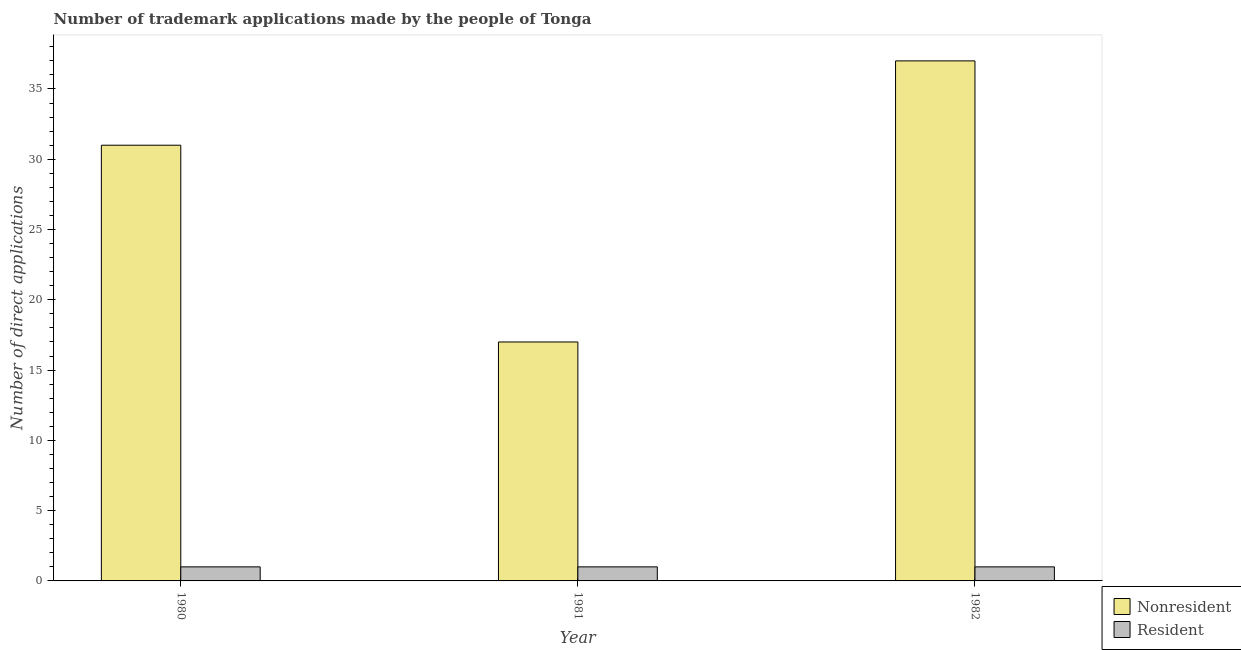How many groups of bars are there?
Ensure brevity in your answer.  3. How many bars are there on the 2nd tick from the left?
Provide a short and direct response. 2. How many bars are there on the 2nd tick from the right?
Provide a short and direct response. 2. In how many cases, is the number of bars for a given year not equal to the number of legend labels?
Offer a very short reply. 0. What is the number of trademark applications made by residents in 1982?
Ensure brevity in your answer.  1. Across all years, what is the maximum number of trademark applications made by residents?
Offer a terse response. 1. Across all years, what is the minimum number of trademark applications made by non residents?
Provide a short and direct response. 17. What is the total number of trademark applications made by residents in the graph?
Offer a very short reply. 3. What is the difference between the number of trademark applications made by non residents in 1982 and the number of trademark applications made by residents in 1980?
Keep it short and to the point. 6. What is the average number of trademark applications made by non residents per year?
Make the answer very short. 28.33. In the year 1982, what is the difference between the number of trademark applications made by residents and number of trademark applications made by non residents?
Make the answer very short. 0. In how many years, is the number of trademark applications made by residents greater than 4?
Provide a succinct answer. 0. What is the ratio of the number of trademark applications made by residents in 1980 to that in 1982?
Ensure brevity in your answer.  1. Is the number of trademark applications made by residents in 1980 less than that in 1982?
Your response must be concise. No. What is the difference between the highest and the second highest number of trademark applications made by non residents?
Your answer should be compact. 6. What is the difference between the highest and the lowest number of trademark applications made by non residents?
Keep it short and to the point. 20. In how many years, is the number of trademark applications made by non residents greater than the average number of trademark applications made by non residents taken over all years?
Your answer should be compact. 2. Is the sum of the number of trademark applications made by residents in 1981 and 1982 greater than the maximum number of trademark applications made by non residents across all years?
Make the answer very short. Yes. What does the 2nd bar from the left in 1982 represents?
Your answer should be very brief. Resident. What does the 1st bar from the right in 1982 represents?
Make the answer very short. Resident. Are all the bars in the graph horizontal?
Provide a succinct answer. No. How many years are there in the graph?
Provide a short and direct response. 3. What is the difference between two consecutive major ticks on the Y-axis?
Give a very brief answer. 5. Does the graph contain grids?
Offer a terse response. No. Where does the legend appear in the graph?
Your answer should be compact. Bottom right. How many legend labels are there?
Your answer should be very brief. 2. How are the legend labels stacked?
Make the answer very short. Vertical. What is the title of the graph?
Offer a very short reply. Number of trademark applications made by the people of Tonga. Does "Researchers" appear as one of the legend labels in the graph?
Make the answer very short. No. What is the label or title of the Y-axis?
Your answer should be compact. Number of direct applications. What is the Number of direct applications of Nonresident in 1980?
Offer a very short reply. 31. What is the Number of direct applications of Resident in 1980?
Provide a succinct answer. 1. What is the Number of direct applications of Resident in 1981?
Your answer should be very brief. 1. What is the Number of direct applications of Nonresident in 1982?
Give a very brief answer. 37. What is the Number of direct applications of Resident in 1982?
Offer a very short reply. 1. Across all years, what is the minimum Number of direct applications in Nonresident?
Keep it short and to the point. 17. What is the total Number of direct applications in Resident in the graph?
Offer a terse response. 3. What is the difference between the Number of direct applications of Nonresident in 1980 and that in 1982?
Keep it short and to the point. -6. What is the difference between the Number of direct applications of Resident in 1981 and that in 1982?
Offer a very short reply. 0. What is the difference between the Number of direct applications in Nonresident in 1980 and the Number of direct applications in Resident in 1981?
Offer a terse response. 30. What is the difference between the Number of direct applications in Nonresident in 1980 and the Number of direct applications in Resident in 1982?
Keep it short and to the point. 30. What is the difference between the Number of direct applications of Nonresident in 1981 and the Number of direct applications of Resident in 1982?
Your response must be concise. 16. What is the average Number of direct applications in Nonresident per year?
Your answer should be very brief. 28.33. What is the average Number of direct applications of Resident per year?
Offer a terse response. 1. In the year 1981, what is the difference between the Number of direct applications in Nonresident and Number of direct applications in Resident?
Your answer should be compact. 16. In the year 1982, what is the difference between the Number of direct applications of Nonresident and Number of direct applications of Resident?
Offer a terse response. 36. What is the ratio of the Number of direct applications of Nonresident in 1980 to that in 1981?
Your answer should be very brief. 1.82. What is the ratio of the Number of direct applications in Resident in 1980 to that in 1981?
Offer a terse response. 1. What is the ratio of the Number of direct applications in Nonresident in 1980 to that in 1982?
Keep it short and to the point. 0.84. What is the ratio of the Number of direct applications of Nonresident in 1981 to that in 1982?
Provide a short and direct response. 0.46. What is the ratio of the Number of direct applications of Resident in 1981 to that in 1982?
Your answer should be very brief. 1. What is the difference between the highest and the second highest Number of direct applications in Nonresident?
Give a very brief answer. 6. What is the difference between the highest and the second highest Number of direct applications of Resident?
Your answer should be very brief. 0. What is the difference between the highest and the lowest Number of direct applications in Nonresident?
Your answer should be compact. 20. 